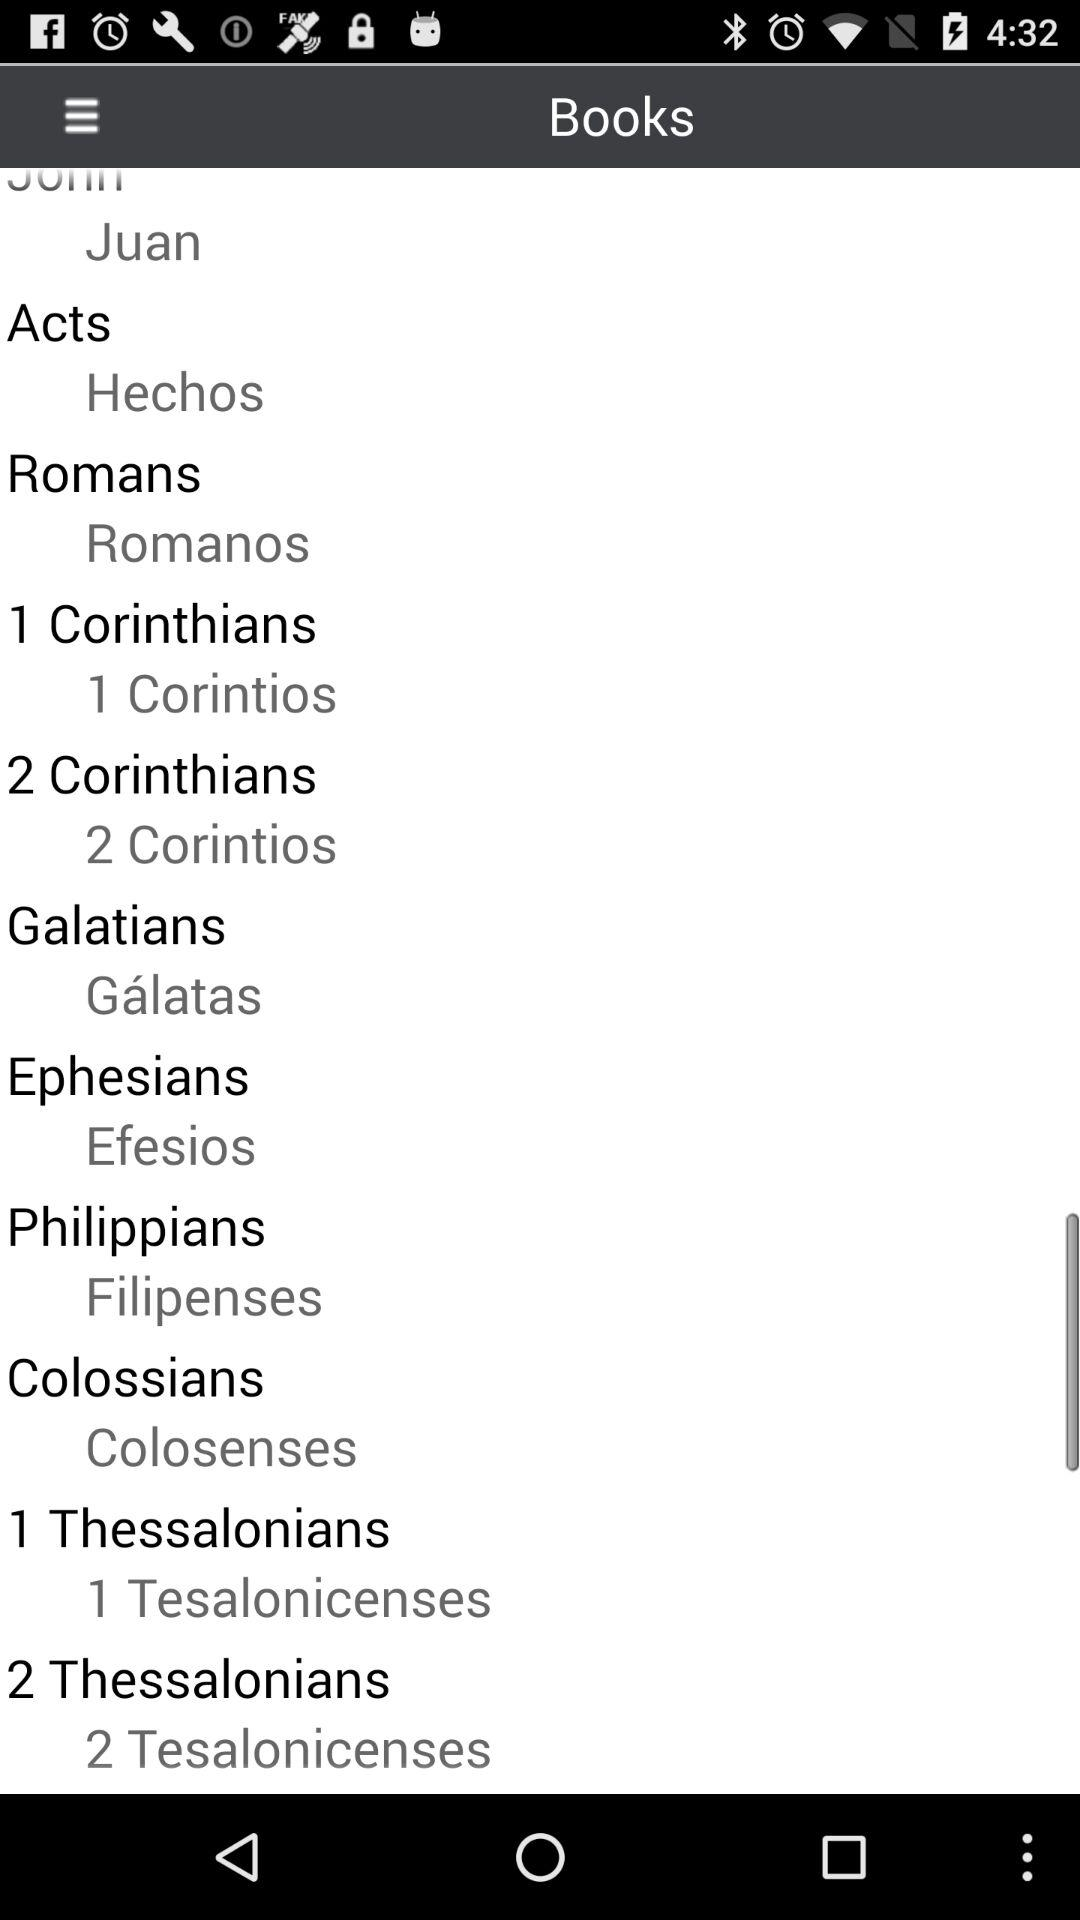What is the Spanish name of the book "Ephesians"? The Spanish name of the book "Ephesians" is "Efesios". 